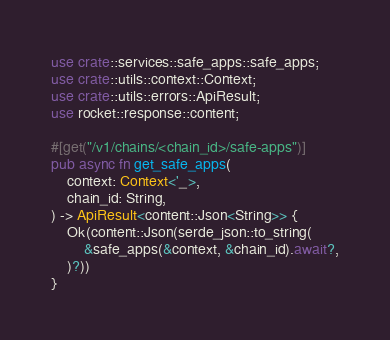Convert code to text. <code><loc_0><loc_0><loc_500><loc_500><_Rust_>use crate::services::safe_apps::safe_apps;
use crate::utils::context::Context;
use crate::utils::errors::ApiResult;
use rocket::response::content;

#[get("/v1/chains/<chain_id>/safe-apps")]
pub async fn get_safe_apps(
    context: Context<'_>,
    chain_id: String,
) -> ApiResult<content::Json<String>> {
    Ok(content::Json(serde_json::to_string(
        &safe_apps(&context, &chain_id).await?,
    )?))
}
</code> 